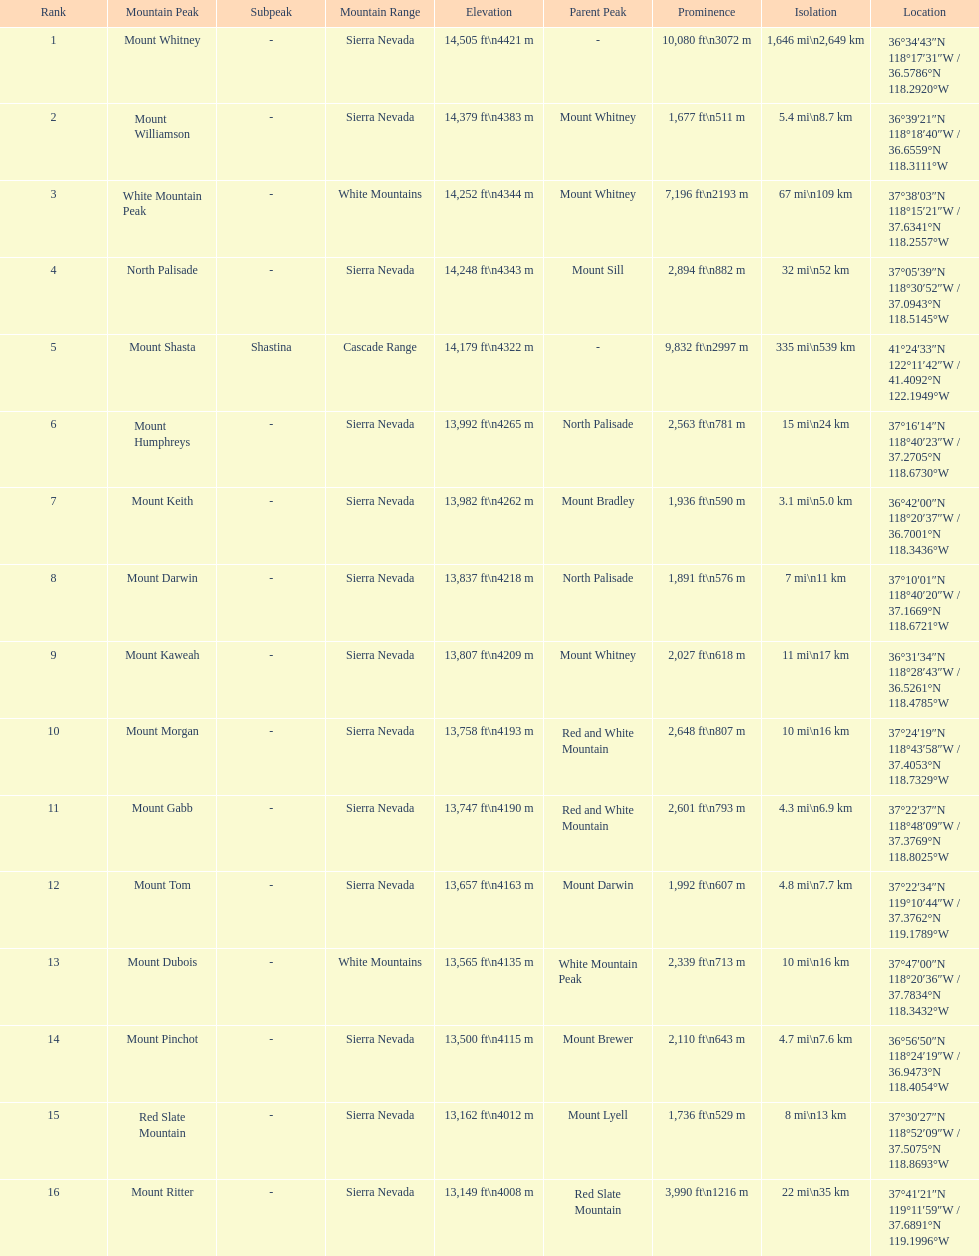What is the only mountain peak listed for the cascade range? Mount Shasta. 